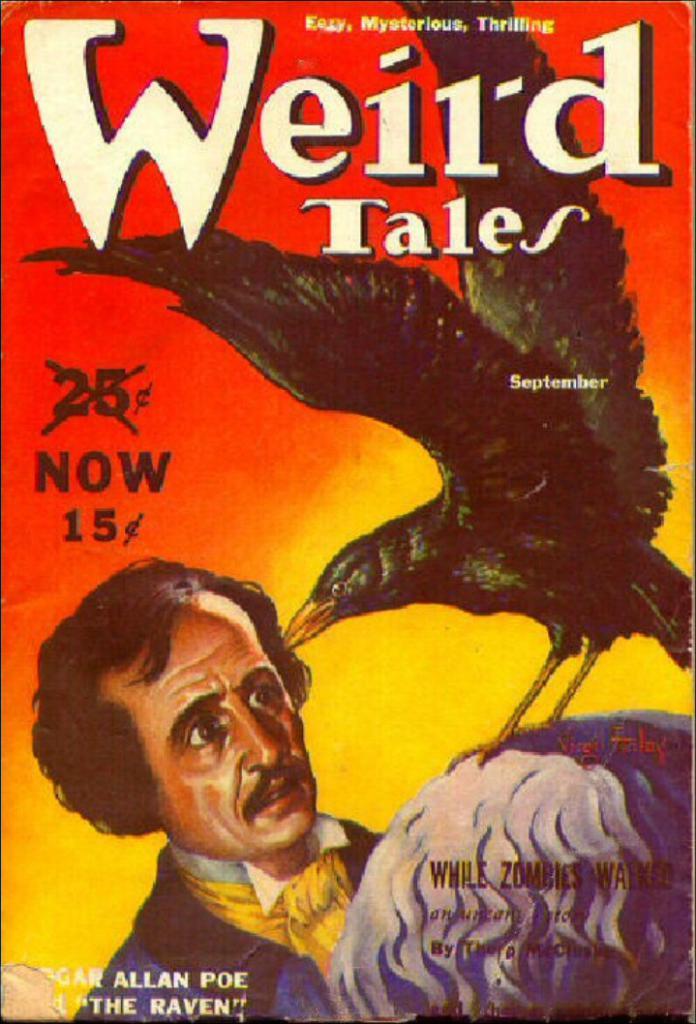What is the new price of this publication?
Make the answer very short. 15 cents. What is the name of this?
Provide a succinct answer. Weird tales. 